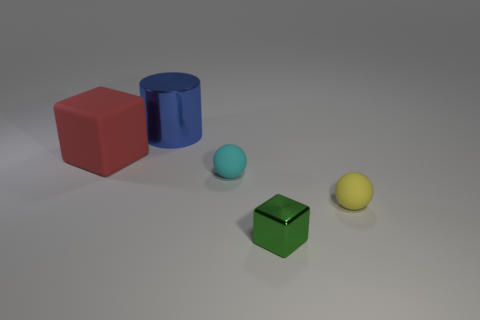What number of blocks are both in front of the red rubber cube and on the left side of the large blue metal thing?
Provide a short and direct response. 0. There is a small ball to the right of the green shiny thing; what is it made of?
Your answer should be compact. Rubber. How many tiny spheres have the same color as the large metallic thing?
Keep it short and to the point. 0. The red object that is made of the same material as the small yellow object is what size?
Provide a succinct answer. Large. What number of objects are either red matte blocks or cyan objects?
Your response must be concise. 2. The ball to the left of the small yellow rubber ball is what color?
Give a very brief answer. Cyan. There is a red object that is the same shape as the green object; what size is it?
Provide a short and direct response. Large. How many things are things to the left of the tiny cyan rubber sphere or cubes that are in front of the red matte block?
Provide a short and direct response. 3. What size is the rubber object that is both to the left of the tiny metallic block and right of the large cube?
Offer a very short reply. Small. There is a tiny green object; does it have the same shape as the thing left of the big cylinder?
Your answer should be compact. Yes. 